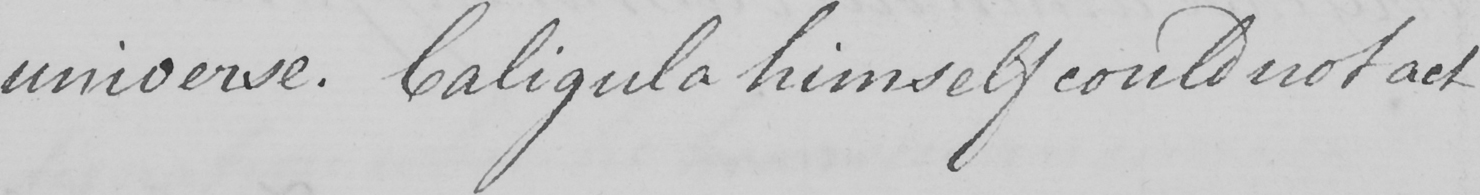Please provide the text content of this handwritten line. universe . Caligula himself could not act 